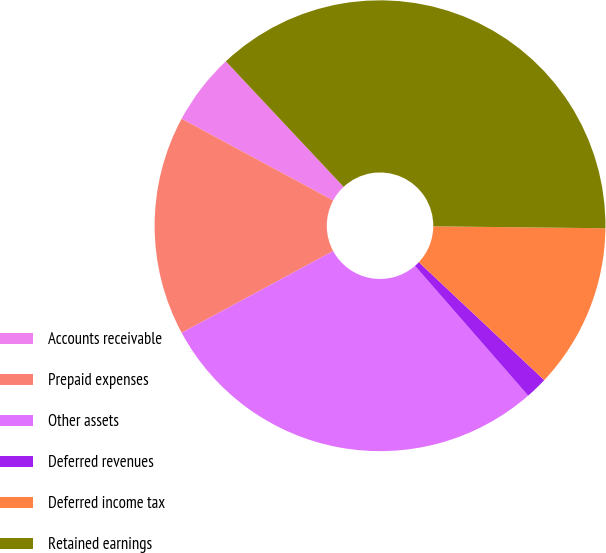<chart> <loc_0><loc_0><loc_500><loc_500><pie_chart><fcel>Accounts receivable<fcel>Prepaid expenses<fcel>Other assets<fcel>Deferred revenues<fcel>Deferred income tax<fcel>Retained earnings<nl><fcel>5.14%<fcel>15.75%<fcel>28.53%<fcel>1.58%<fcel>11.83%<fcel>37.17%<nl></chart> 